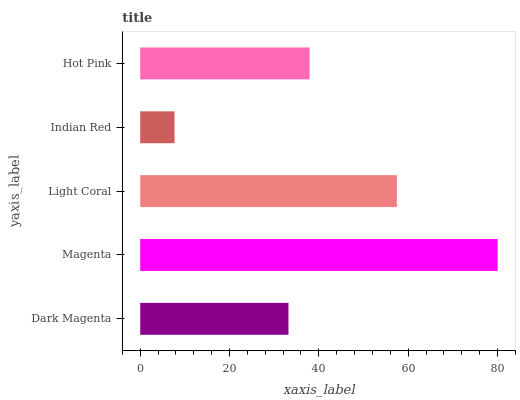Is Indian Red the minimum?
Answer yes or no. Yes. Is Magenta the maximum?
Answer yes or no. Yes. Is Light Coral the minimum?
Answer yes or no. No. Is Light Coral the maximum?
Answer yes or no. No. Is Magenta greater than Light Coral?
Answer yes or no. Yes. Is Light Coral less than Magenta?
Answer yes or no. Yes. Is Light Coral greater than Magenta?
Answer yes or no. No. Is Magenta less than Light Coral?
Answer yes or no. No. Is Hot Pink the high median?
Answer yes or no. Yes. Is Hot Pink the low median?
Answer yes or no. Yes. Is Dark Magenta the high median?
Answer yes or no. No. Is Light Coral the low median?
Answer yes or no. No. 